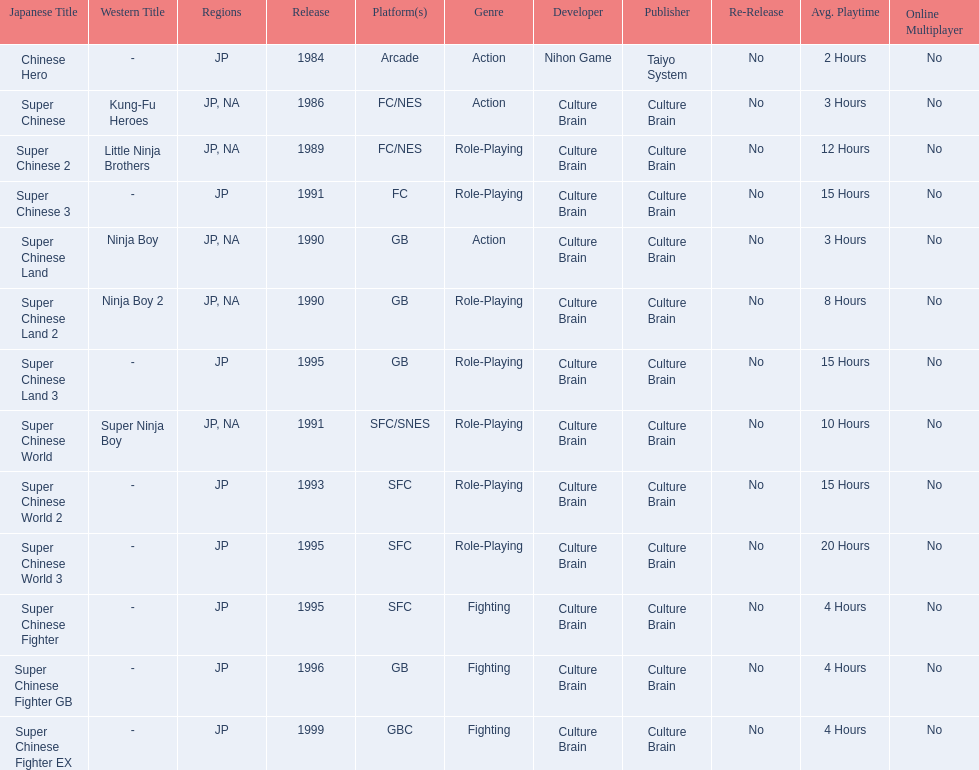Would you be able to parse every entry in this table? {'header': ['Japanese Title', 'Western Title', 'Regions', 'Release', 'Platform(s)', 'Genre', 'Developer', 'Publisher', 'Re-Release', 'Avg. Playtime', 'Online Multiplayer'], 'rows': [['Chinese Hero', '-', 'JP', '1984', 'Arcade', 'Action', 'Nihon Game', 'Taiyo System', 'No', '2 Hours', 'No'], ['Super Chinese', 'Kung-Fu Heroes', 'JP, NA', '1986', 'FC/NES', 'Action', 'Culture Brain', 'Culture Brain', 'No', '3 Hours', 'No'], ['Super Chinese 2', 'Little Ninja Brothers', 'JP, NA', '1989', 'FC/NES', 'Role-Playing', 'Culture Brain', 'Culture Brain', 'No', '12 Hours', 'No'], ['Super Chinese 3', '-', 'JP', '1991', 'FC', 'Role-Playing', 'Culture Brain', 'Culture Brain', 'No', '15 Hours', 'No'], ['Super Chinese Land', 'Ninja Boy', 'JP, NA', '1990', 'GB', 'Action', 'Culture Brain', 'Culture Brain', 'No', '3 Hours', 'No'], ['Super Chinese Land 2', 'Ninja Boy 2', 'JP, NA', '1990', 'GB', 'Role-Playing', 'Culture Brain', 'Culture Brain', 'No', '8 Hours', 'No'], ['Super Chinese Land 3', '-', 'JP', '1995', 'GB', 'Role-Playing', 'Culture Brain', 'Culture Brain', 'No', '15 Hours', 'No'], ['Super Chinese World', 'Super Ninja Boy', 'JP, NA', '1991', 'SFC/SNES', 'Role-Playing', 'Culture Brain', 'Culture Brain', 'No', '10 Hours', 'No'], ['Super Chinese World 2', '-', 'JP', '1993', 'SFC', 'Role-Playing', 'Culture Brain', 'Culture Brain', 'No', '15 Hours', 'No'], ['Super Chinese World 3', '-', 'JP', '1995', 'SFC', 'Role-Playing', 'Culture Brain', 'Culture Brain', 'No', '20 Hours', 'No'], ['Super Chinese Fighter', '-', 'JP', '1995', 'SFC', 'Fighting', 'Culture Brain', 'Culture Brain', 'No', '4 Hours', 'No'], ['Super Chinese Fighter GB', '-', 'JP', '1996', 'GB', 'Fighting', 'Culture Brain', 'Culture Brain', 'No', '4 Hours', 'No'], ['Super Chinese Fighter EX', '-', 'JP', '1999', 'GBC', 'Fighting', 'Culture Brain', 'Culture Brain', 'No', '4 Hours', 'No']]} Which titles were released in north america? Super Chinese, Super Chinese 2, Super Chinese Land, Super Chinese Land 2, Super Chinese World. Of those, which had the least releases? Super Chinese World. 